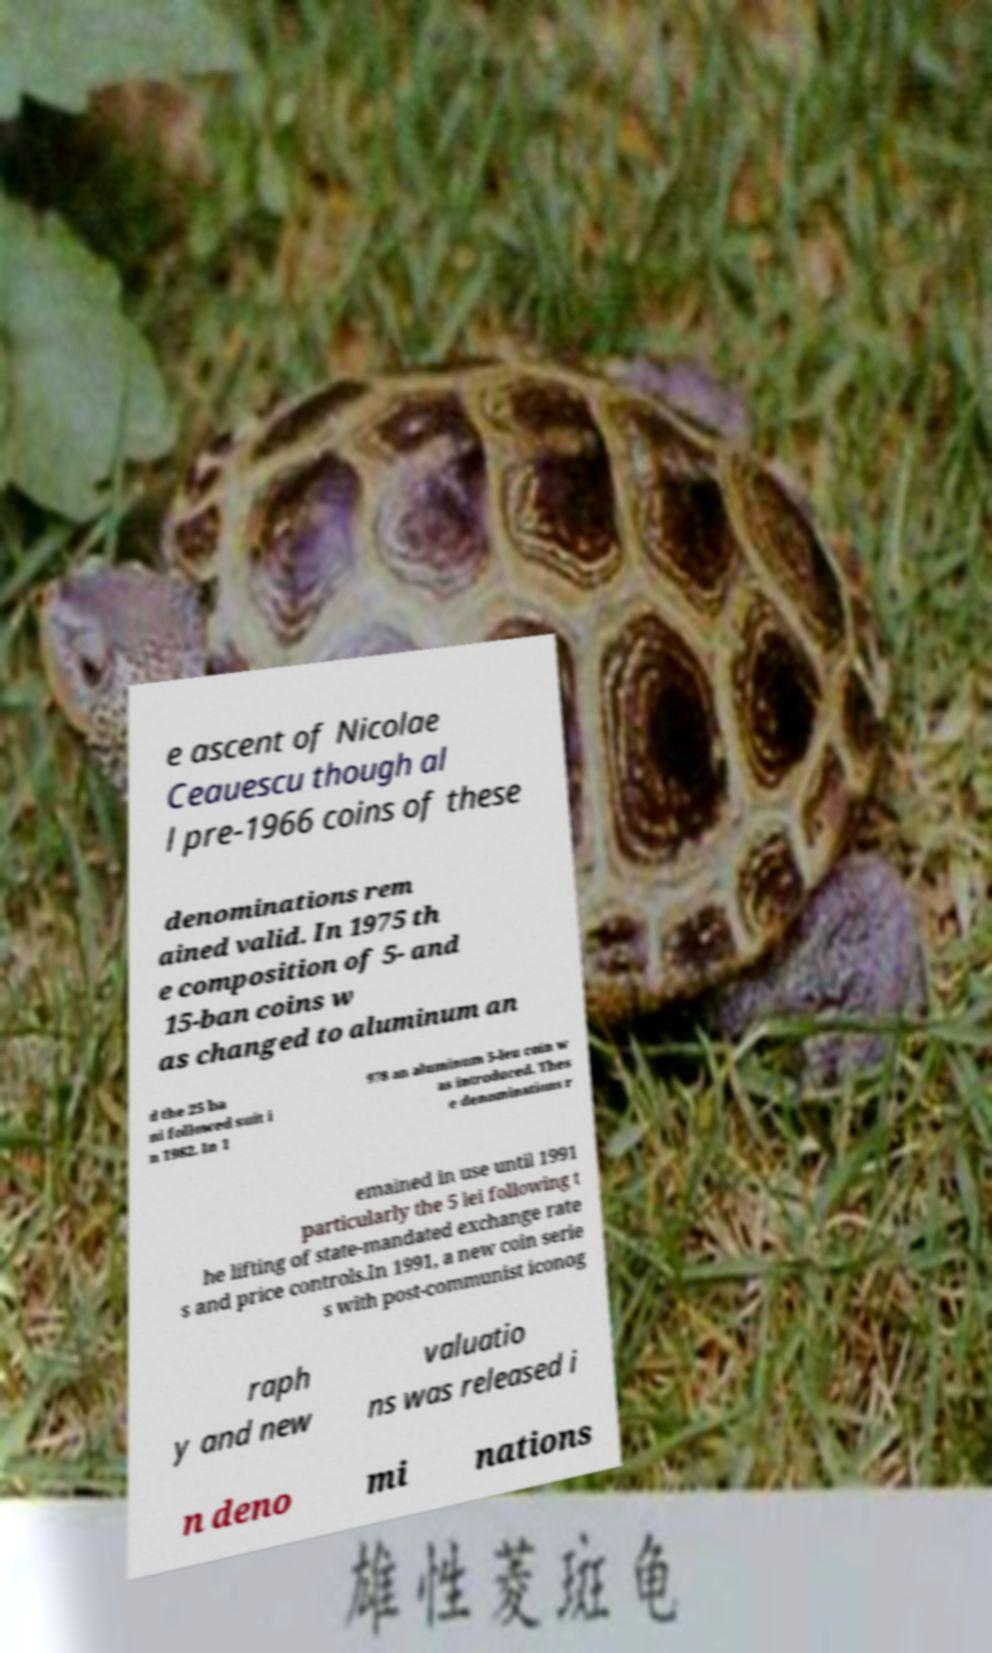Can you read and provide the text displayed in the image?This photo seems to have some interesting text. Can you extract and type it out for me? e ascent of Nicolae Ceauescu though al l pre-1966 coins of these denominations rem ained valid. In 1975 th e composition of 5- and 15-ban coins w as changed to aluminum an d the 25 ba ni followed suit i n 1982. In 1 978 an aluminum 5-leu coin w as introduced. Thes e denominations r emained in use until 1991 particularly the 5 lei following t he lifting of state-mandated exchange rate s and price controls.In 1991, a new coin serie s with post-communist iconog raph y and new valuatio ns was released i n deno mi nations 